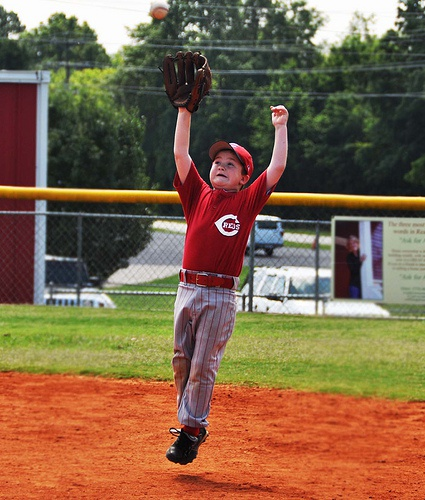Describe the objects in this image and their specific colors. I can see people in ivory, maroon, black, gray, and brown tones, car in ivory, lightgray, darkgray, gray, and lightblue tones, car in ivory, black, gray, lightgray, and darkgray tones, baseball glove in ivory, black, maroon, and gray tones, and car in ivory, black, gray, and lightblue tones in this image. 